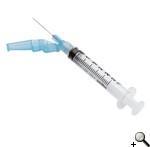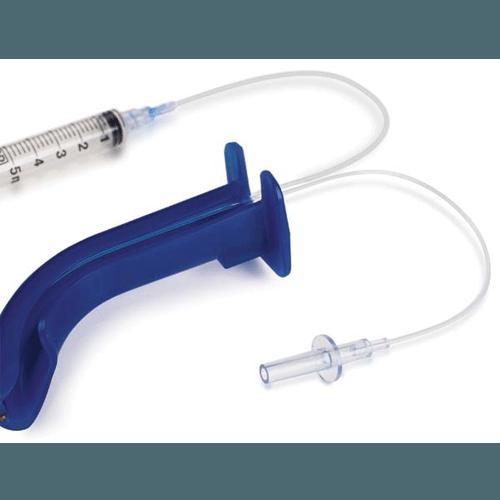The first image is the image on the left, the second image is the image on the right. Examine the images to the left and right. Is the description "There are two pieces of flexible tubing in the image on the right." accurate? Answer yes or no. Yes. 